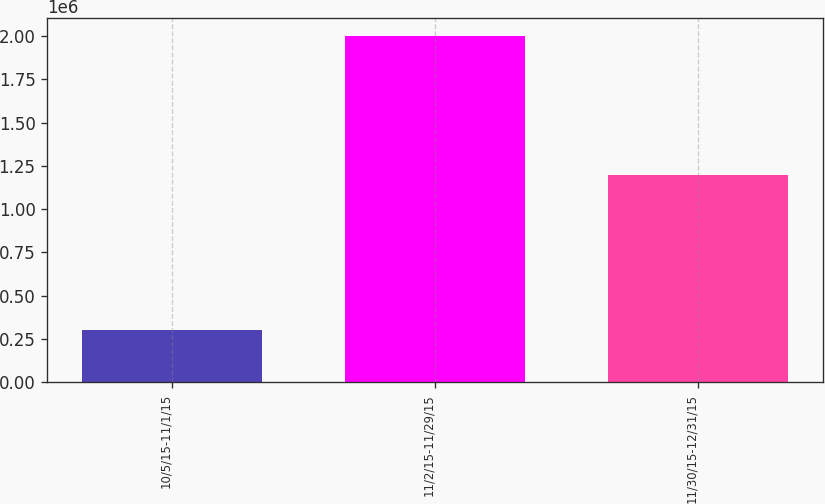Convert chart to OTSL. <chart><loc_0><loc_0><loc_500><loc_500><bar_chart><fcel>10/5/15-11/1/15<fcel>11/2/15-11/29/15<fcel>11/30/15-12/31/15<nl><fcel>305000<fcel>2.002e+06<fcel>1.2e+06<nl></chart> 